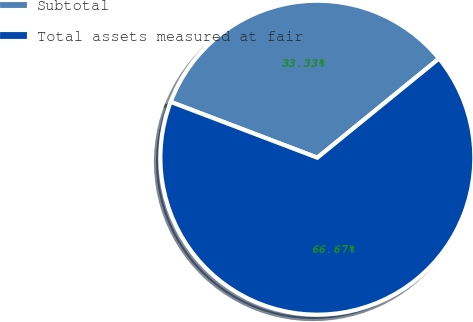Convert chart to OTSL. <chart><loc_0><loc_0><loc_500><loc_500><pie_chart><fcel>Subtotal<fcel>Total assets measured at fair<nl><fcel>33.33%<fcel>66.67%<nl></chart> 